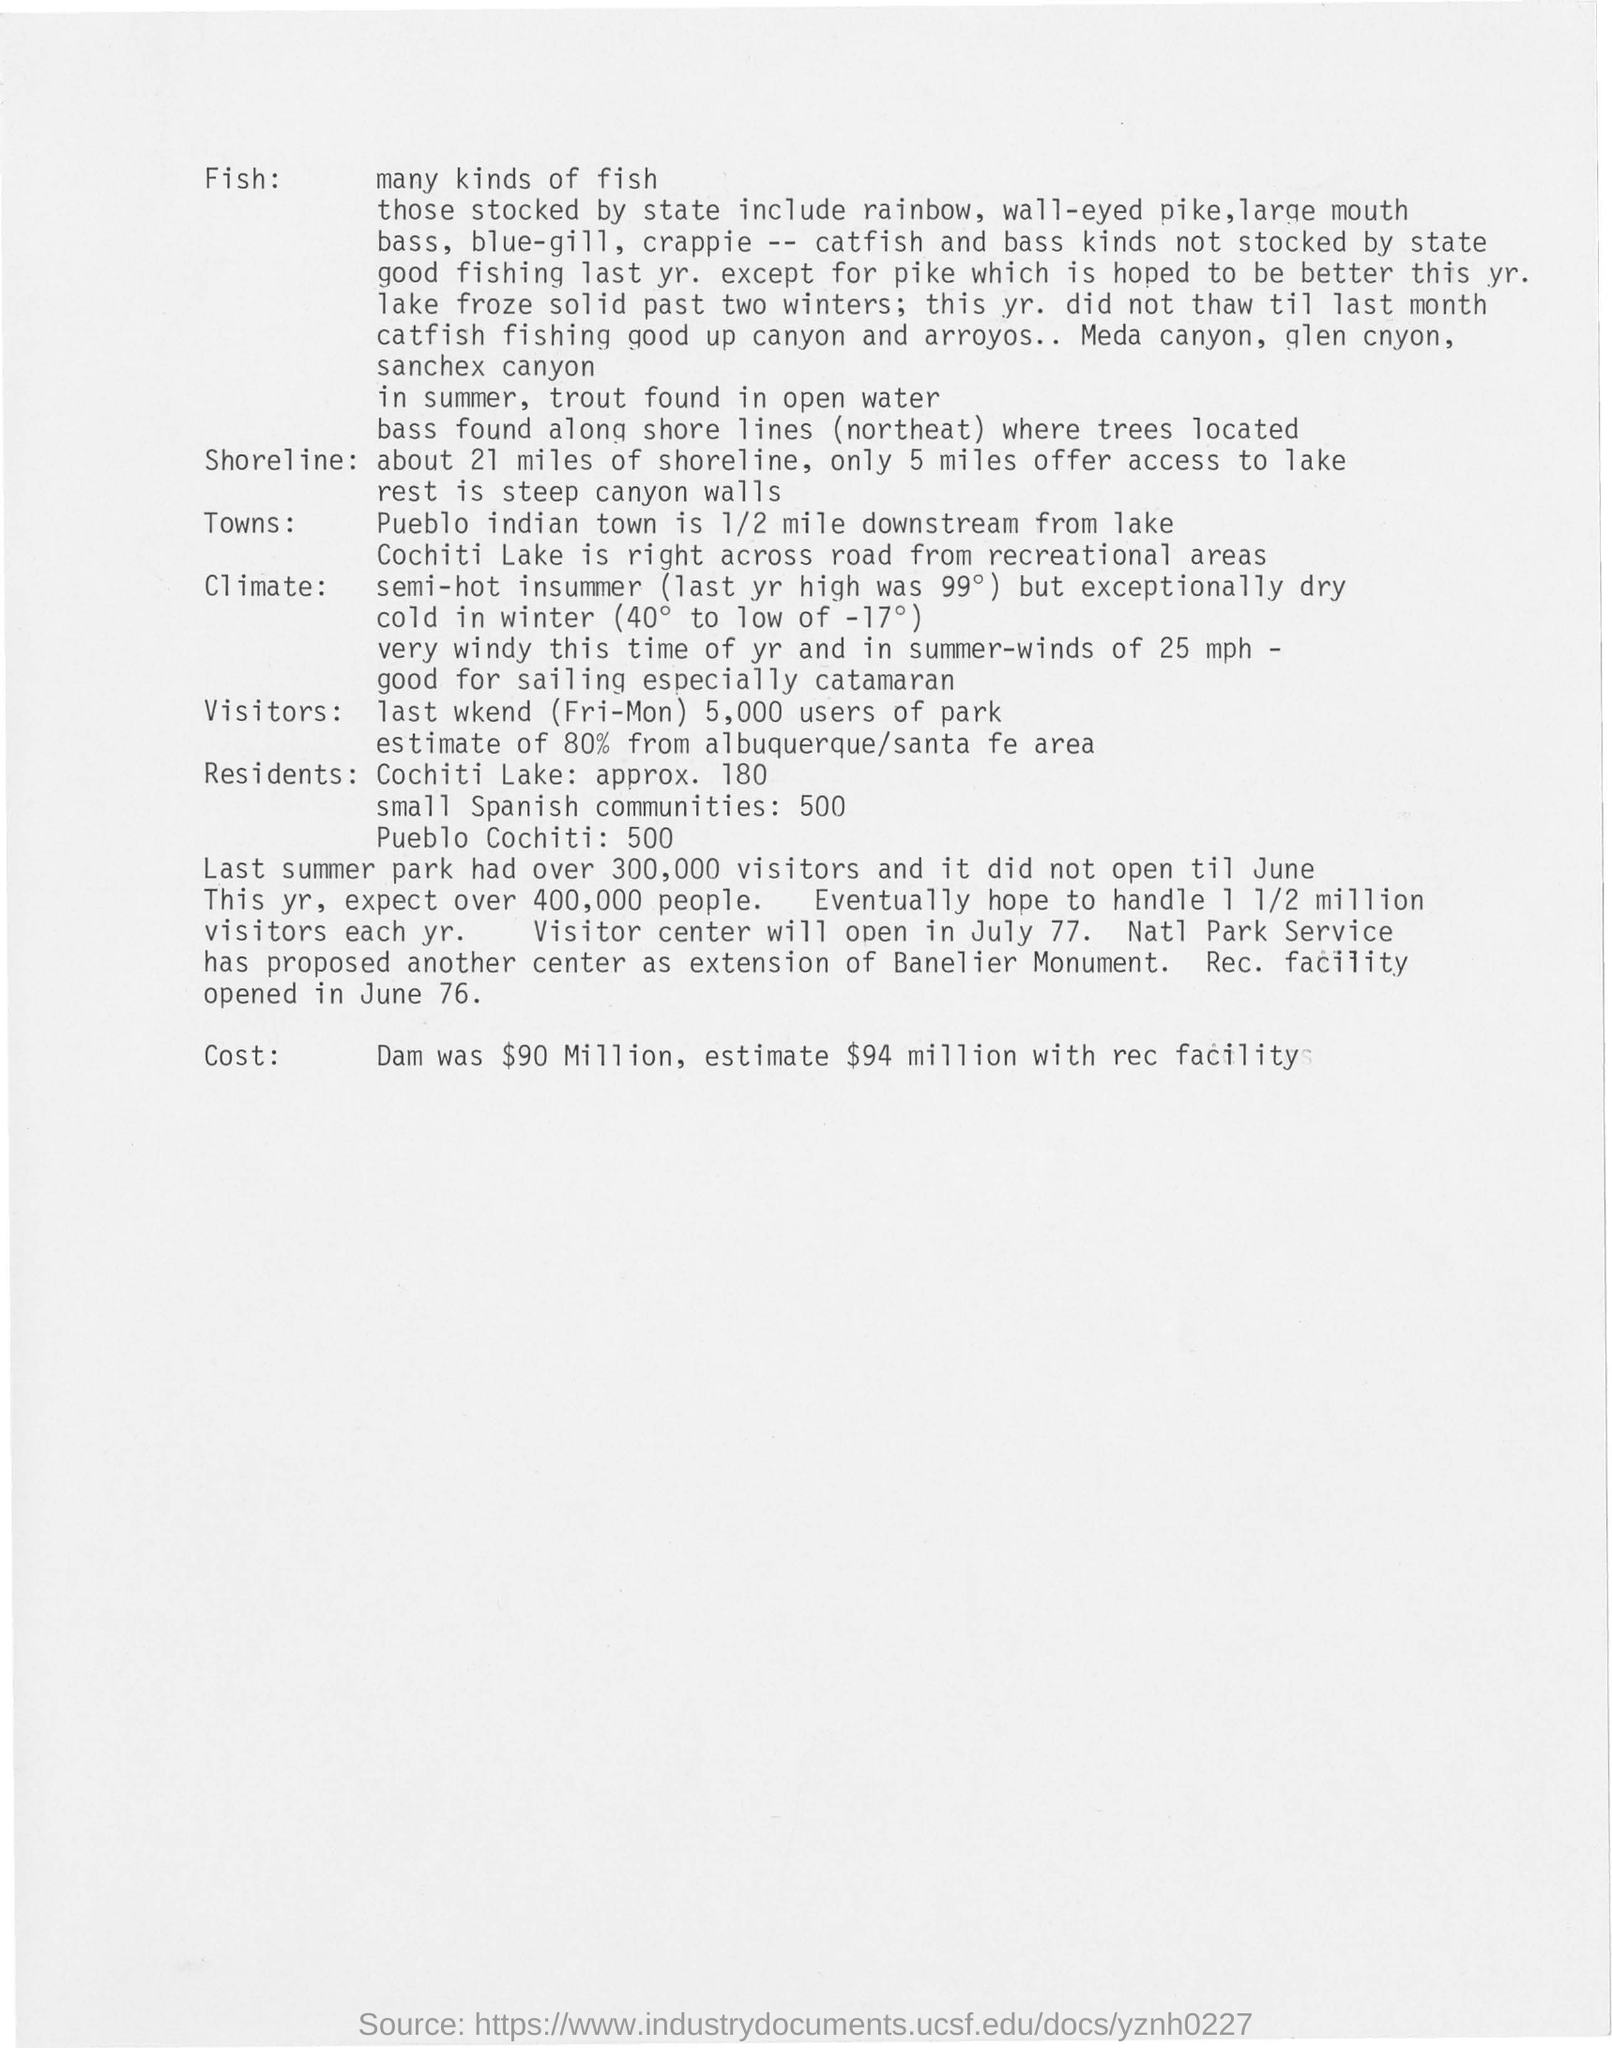How many miles are the shoreline?
Your response must be concise. About 21 miles. When did the Rec. facility opened?
Make the answer very short. June 76. What was the cost of Dam?
Keep it short and to the point. $90 million. How many visitors were there in the  park last summer?
Ensure brevity in your answer.  Over 300,000 visitors. 